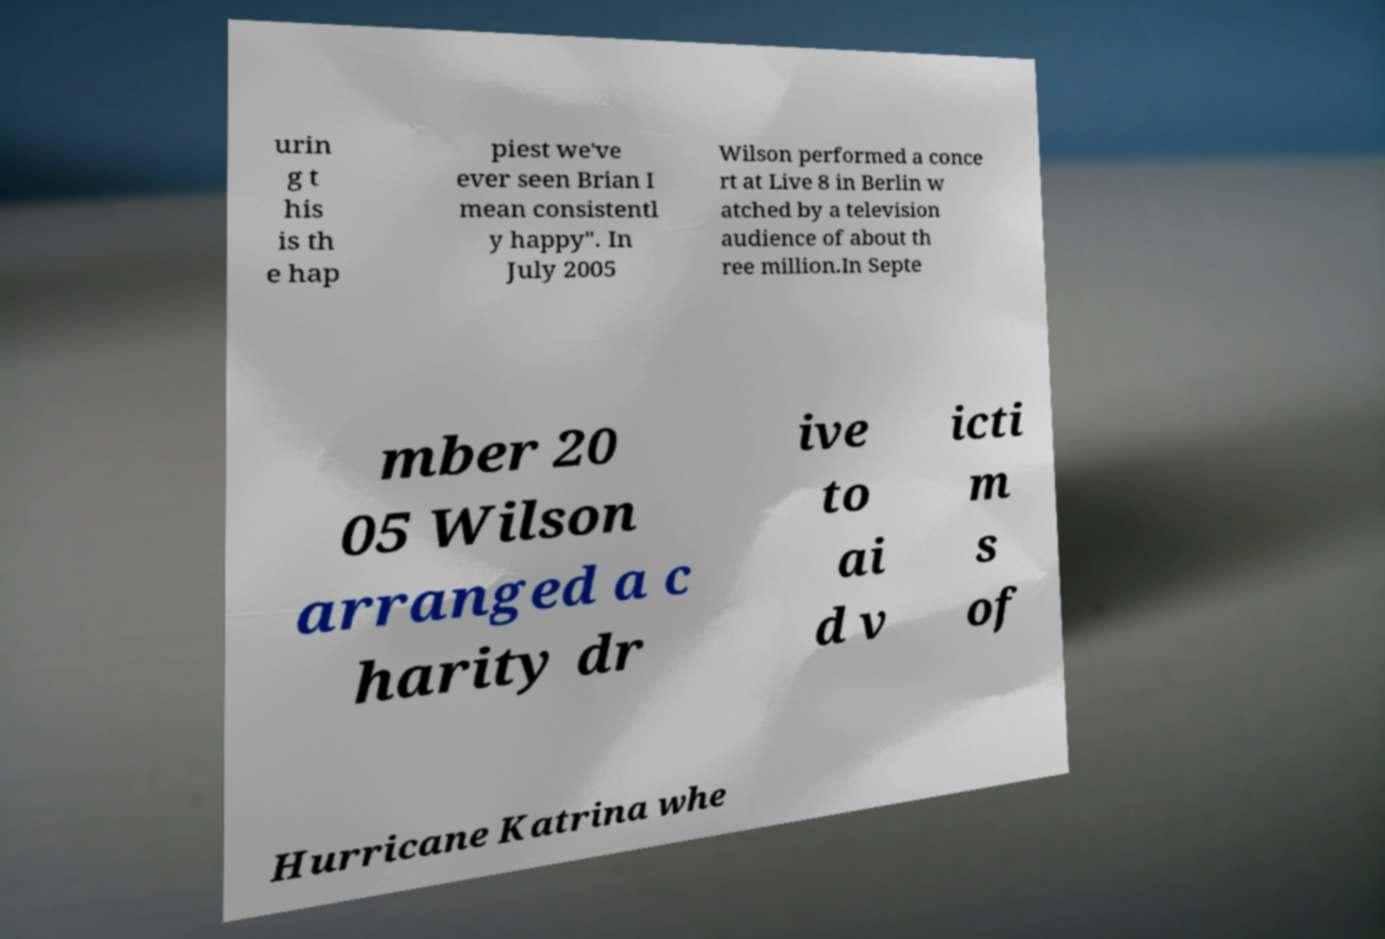Can you accurately transcribe the text from the provided image for me? urin g t his is th e hap piest we've ever seen Brian I mean consistentl y happy". In July 2005 Wilson performed a conce rt at Live 8 in Berlin w atched by a television audience of about th ree million.In Septe mber 20 05 Wilson arranged a c harity dr ive to ai d v icti m s of Hurricane Katrina whe 